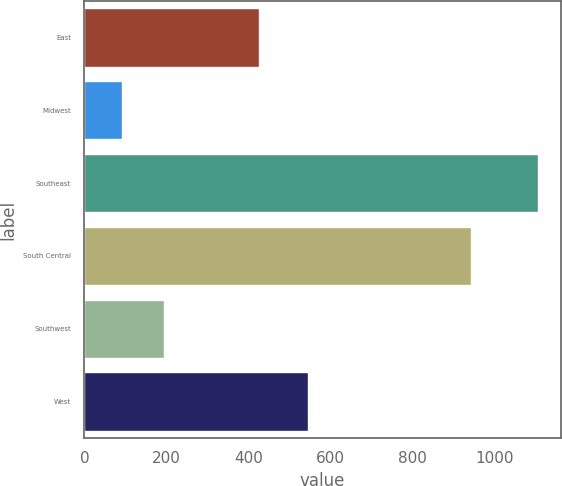Convert chart. <chart><loc_0><loc_0><loc_500><loc_500><bar_chart><fcel>East<fcel>Midwest<fcel>Southeast<fcel>South Central<fcel>Southwest<fcel>West<nl><fcel>425.4<fcel>91.6<fcel>1105.9<fcel>942.5<fcel>193.03<fcel>544.7<nl></chart> 